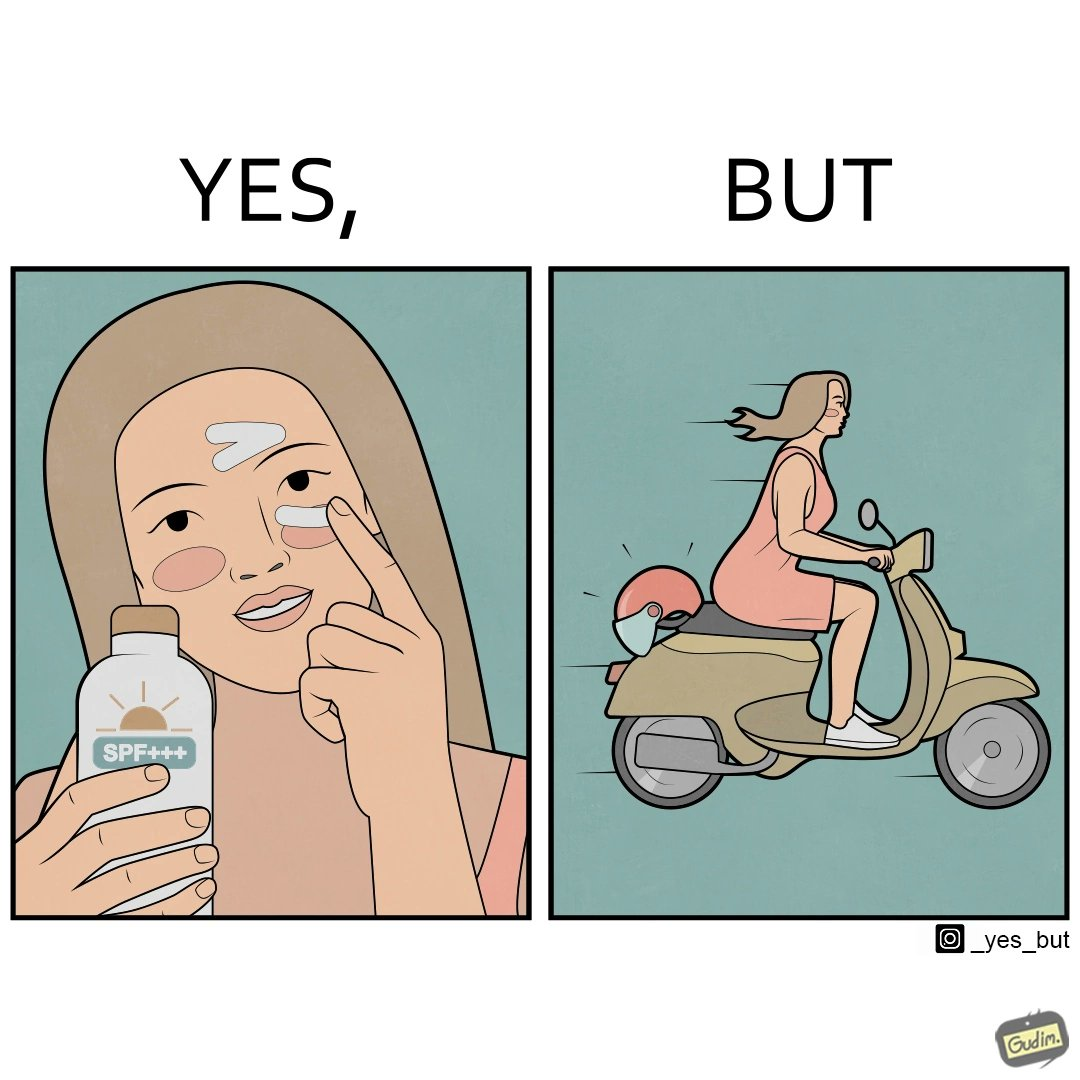What does this image depict? The image is funny because while the woman is concerned about protection from the sun rays, she is not concerned about her safety while riding a scooter. 